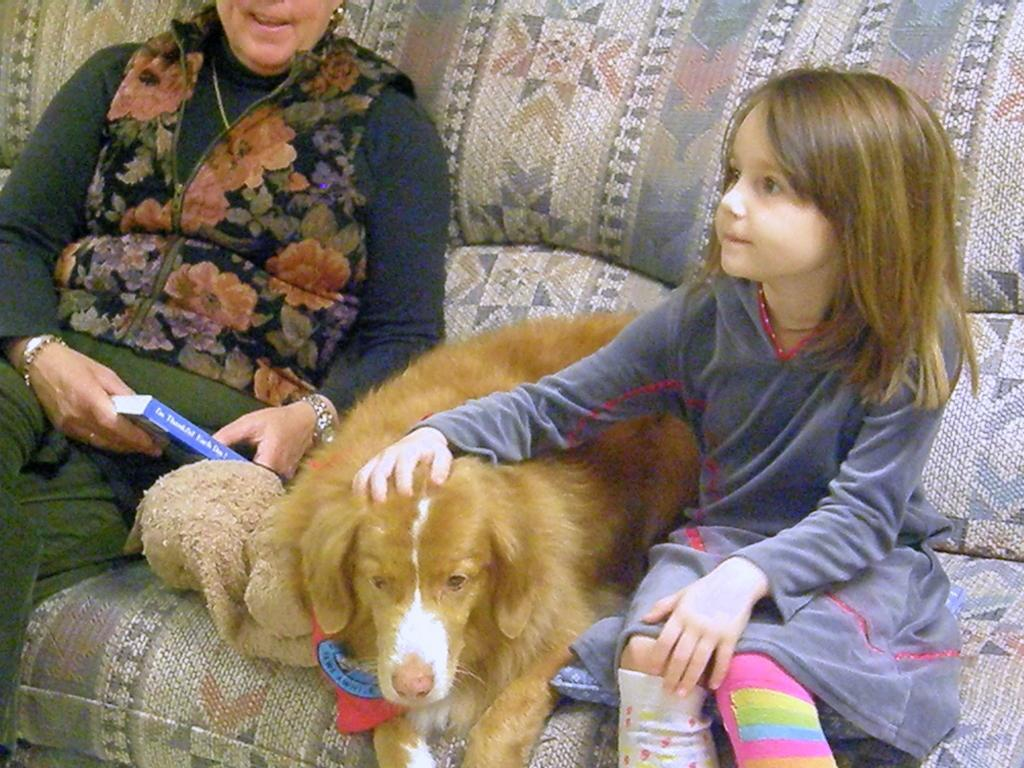Who is present in the image? There is a woman, a dog, and a child in the image. What is the woman holding in the image? The woman is holding a book in the image. Where are the woman, dog, and child sitting? They are sitting on a sofa in the image. What type of zinc can be seen in the middle of the image? There is no zinc present in the image. 